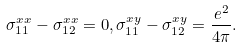<formula> <loc_0><loc_0><loc_500><loc_500>\sigma ^ { x x } _ { 1 1 } - \sigma ^ { x x } _ { 1 2 } = 0 , \sigma ^ { x y } _ { 1 1 } - \sigma ^ { x y } _ { 1 2 } = \frac { e ^ { 2 } } { 4 \pi } .</formula> 